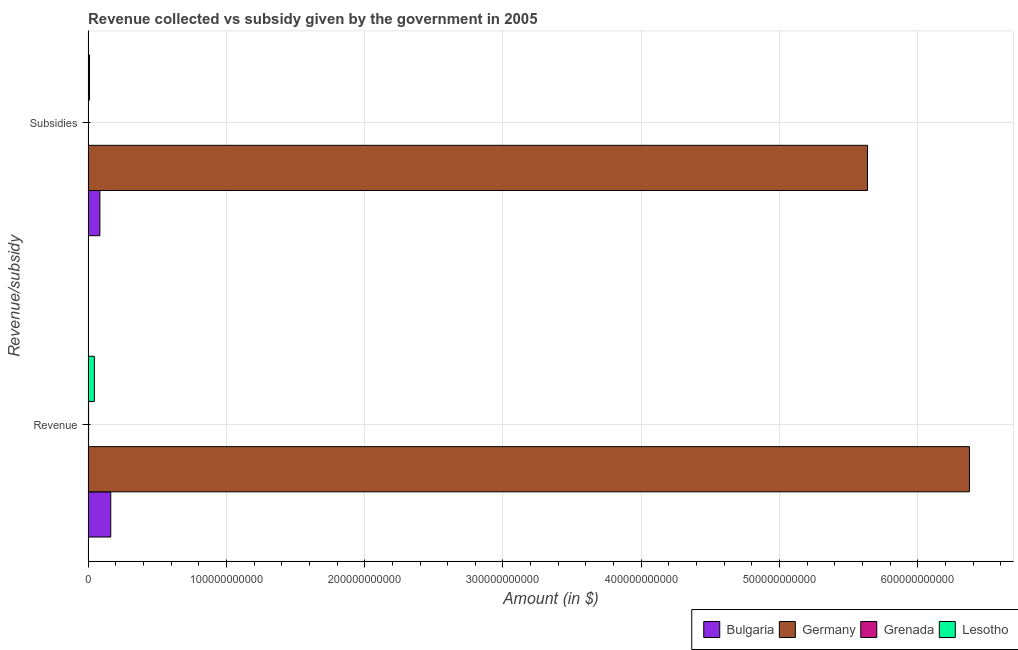How many groups of bars are there?
Offer a very short reply. 2. Are the number of bars per tick equal to the number of legend labels?
Offer a very short reply. Yes. How many bars are there on the 1st tick from the top?
Offer a very short reply. 4. What is the label of the 2nd group of bars from the top?
Your answer should be compact. Revenue. What is the amount of subsidies given in Bulgaria?
Make the answer very short. 8.53e+09. Across all countries, what is the maximum amount of subsidies given?
Ensure brevity in your answer.  5.64e+11. Across all countries, what is the minimum amount of subsidies given?
Your answer should be compact. 5.46e+07. In which country was the amount of revenue collected maximum?
Provide a short and direct response. Germany. In which country was the amount of revenue collected minimum?
Give a very brief answer. Grenada. What is the total amount of subsidies given in the graph?
Provide a short and direct response. 5.73e+11. What is the difference between the amount of revenue collected in Grenada and that in Lesotho?
Provide a short and direct response. -4.17e+09. What is the difference between the amount of revenue collected in Germany and the amount of subsidies given in Grenada?
Provide a short and direct response. 6.37e+11. What is the average amount of revenue collected per country?
Your answer should be very brief. 1.65e+11. What is the difference between the amount of subsidies given and amount of revenue collected in Lesotho?
Offer a very short reply. -3.48e+09. In how many countries, is the amount of subsidies given greater than 440000000000 $?
Your answer should be very brief. 1. What is the ratio of the amount of subsidies given in Bulgaria to that in Lesotho?
Your answer should be compact. 8.08. Is the amount of revenue collected in Germany less than that in Lesotho?
Your response must be concise. No. What does the 2nd bar from the top in Subsidies represents?
Your answer should be very brief. Grenada. What does the 4th bar from the bottom in Subsidies represents?
Make the answer very short. Lesotho. Are all the bars in the graph horizontal?
Your answer should be compact. Yes. How many countries are there in the graph?
Provide a short and direct response. 4. What is the difference between two consecutive major ticks on the X-axis?
Your answer should be very brief. 1.00e+11. Does the graph contain any zero values?
Give a very brief answer. No. Does the graph contain grids?
Ensure brevity in your answer.  Yes. How many legend labels are there?
Offer a terse response. 4. What is the title of the graph?
Your answer should be very brief. Revenue collected vs subsidy given by the government in 2005. What is the label or title of the X-axis?
Keep it short and to the point. Amount (in $). What is the label or title of the Y-axis?
Your response must be concise. Revenue/subsidy. What is the Amount (in $) in Bulgaria in Revenue?
Ensure brevity in your answer.  1.64e+1. What is the Amount (in $) of Germany in Revenue?
Offer a terse response. 6.37e+11. What is the Amount (in $) of Grenada in Revenue?
Give a very brief answer. 3.60e+08. What is the Amount (in $) in Lesotho in Revenue?
Provide a succinct answer. 4.53e+09. What is the Amount (in $) in Bulgaria in Subsidies?
Keep it short and to the point. 8.53e+09. What is the Amount (in $) in Germany in Subsidies?
Give a very brief answer. 5.64e+11. What is the Amount (in $) of Grenada in Subsidies?
Make the answer very short. 5.46e+07. What is the Amount (in $) of Lesotho in Subsidies?
Keep it short and to the point. 1.06e+09. Across all Revenue/subsidy, what is the maximum Amount (in $) in Bulgaria?
Your response must be concise. 1.64e+1. Across all Revenue/subsidy, what is the maximum Amount (in $) in Germany?
Provide a short and direct response. 6.37e+11. Across all Revenue/subsidy, what is the maximum Amount (in $) in Grenada?
Provide a short and direct response. 3.60e+08. Across all Revenue/subsidy, what is the maximum Amount (in $) in Lesotho?
Your answer should be very brief. 4.53e+09. Across all Revenue/subsidy, what is the minimum Amount (in $) of Bulgaria?
Your answer should be very brief. 8.53e+09. Across all Revenue/subsidy, what is the minimum Amount (in $) of Germany?
Provide a short and direct response. 5.64e+11. Across all Revenue/subsidy, what is the minimum Amount (in $) of Grenada?
Your answer should be very brief. 5.46e+07. Across all Revenue/subsidy, what is the minimum Amount (in $) in Lesotho?
Your answer should be very brief. 1.06e+09. What is the total Amount (in $) in Bulgaria in the graph?
Provide a succinct answer. 2.49e+1. What is the total Amount (in $) of Germany in the graph?
Your answer should be compact. 1.20e+12. What is the total Amount (in $) of Grenada in the graph?
Offer a terse response. 4.14e+08. What is the total Amount (in $) in Lesotho in the graph?
Your answer should be compact. 5.59e+09. What is the difference between the Amount (in $) in Bulgaria in Revenue and that in Subsidies?
Make the answer very short. 7.85e+09. What is the difference between the Amount (in $) in Germany in Revenue and that in Subsidies?
Give a very brief answer. 7.37e+1. What is the difference between the Amount (in $) in Grenada in Revenue and that in Subsidies?
Give a very brief answer. 3.05e+08. What is the difference between the Amount (in $) of Lesotho in Revenue and that in Subsidies?
Your answer should be very brief. 3.48e+09. What is the difference between the Amount (in $) of Bulgaria in Revenue and the Amount (in $) of Germany in Subsidies?
Your response must be concise. -5.47e+11. What is the difference between the Amount (in $) in Bulgaria in Revenue and the Amount (in $) in Grenada in Subsidies?
Your response must be concise. 1.63e+1. What is the difference between the Amount (in $) of Bulgaria in Revenue and the Amount (in $) of Lesotho in Subsidies?
Offer a very short reply. 1.53e+1. What is the difference between the Amount (in $) in Germany in Revenue and the Amount (in $) in Grenada in Subsidies?
Offer a very short reply. 6.37e+11. What is the difference between the Amount (in $) in Germany in Revenue and the Amount (in $) in Lesotho in Subsidies?
Your answer should be compact. 6.36e+11. What is the difference between the Amount (in $) of Grenada in Revenue and the Amount (in $) of Lesotho in Subsidies?
Provide a short and direct response. -6.96e+08. What is the average Amount (in $) of Bulgaria per Revenue/subsidy?
Your answer should be very brief. 1.25e+1. What is the average Amount (in $) in Germany per Revenue/subsidy?
Ensure brevity in your answer.  6.00e+11. What is the average Amount (in $) in Grenada per Revenue/subsidy?
Your response must be concise. 2.07e+08. What is the average Amount (in $) in Lesotho per Revenue/subsidy?
Give a very brief answer. 2.79e+09. What is the difference between the Amount (in $) of Bulgaria and Amount (in $) of Germany in Revenue?
Offer a terse response. -6.21e+11. What is the difference between the Amount (in $) in Bulgaria and Amount (in $) in Grenada in Revenue?
Offer a very short reply. 1.60e+1. What is the difference between the Amount (in $) in Bulgaria and Amount (in $) in Lesotho in Revenue?
Offer a very short reply. 1.18e+1. What is the difference between the Amount (in $) of Germany and Amount (in $) of Grenada in Revenue?
Provide a short and direct response. 6.37e+11. What is the difference between the Amount (in $) of Germany and Amount (in $) of Lesotho in Revenue?
Your answer should be very brief. 6.33e+11. What is the difference between the Amount (in $) of Grenada and Amount (in $) of Lesotho in Revenue?
Your answer should be compact. -4.17e+09. What is the difference between the Amount (in $) in Bulgaria and Amount (in $) in Germany in Subsidies?
Provide a succinct answer. -5.55e+11. What is the difference between the Amount (in $) of Bulgaria and Amount (in $) of Grenada in Subsidies?
Offer a very short reply. 8.47e+09. What is the difference between the Amount (in $) in Bulgaria and Amount (in $) in Lesotho in Subsidies?
Offer a terse response. 7.47e+09. What is the difference between the Amount (in $) of Germany and Amount (in $) of Grenada in Subsidies?
Provide a short and direct response. 5.64e+11. What is the difference between the Amount (in $) in Germany and Amount (in $) in Lesotho in Subsidies?
Your response must be concise. 5.63e+11. What is the difference between the Amount (in $) of Grenada and Amount (in $) of Lesotho in Subsidies?
Keep it short and to the point. -1.00e+09. What is the ratio of the Amount (in $) in Bulgaria in Revenue to that in Subsidies?
Give a very brief answer. 1.92. What is the ratio of the Amount (in $) of Germany in Revenue to that in Subsidies?
Provide a succinct answer. 1.13. What is the ratio of the Amount (in $) of Grenada in Revenue to that in Subsidies?
Your answer should be very brief. 6.59. What is the ratio of the Amount (in $) in Lesotho in Revenue to that in Subsidies?
Offer a very short reply. 4.29. What is the difference between the highest and the second highest Amount (in $) of Bulgaria?
Offer a very short reply. 7.85e+09. What is the difference between the highest and the second highest Amount (in $) in Germany?
Keep it short and to the point. 7.37e+1. What is the difference between the highest and the second highest Amount (in $) of Grenada?
Offer a terse response. 3.05e+08. What is the difference between the highest and the second highest Amount (in $) of Lesotho?
Give a very brief answer. 3.48e+09. What is the difference between the highest and the lowest Amount (in $) in Bulgaria?
Offer a terse response. 7.85e+09. What is the difference between the highest and the lowest Amount (in $) of Germany?
Your answer should be very brief. 7.37e+1. What is the difference between the highest and the lowest Amount (in $) in Grenada?
Keep it short and to the point. 3.05e+08. What is the difference between the highest and the lowest Amount (in $) in Lesotho?
Offer a terse response. 3.48e+09. 